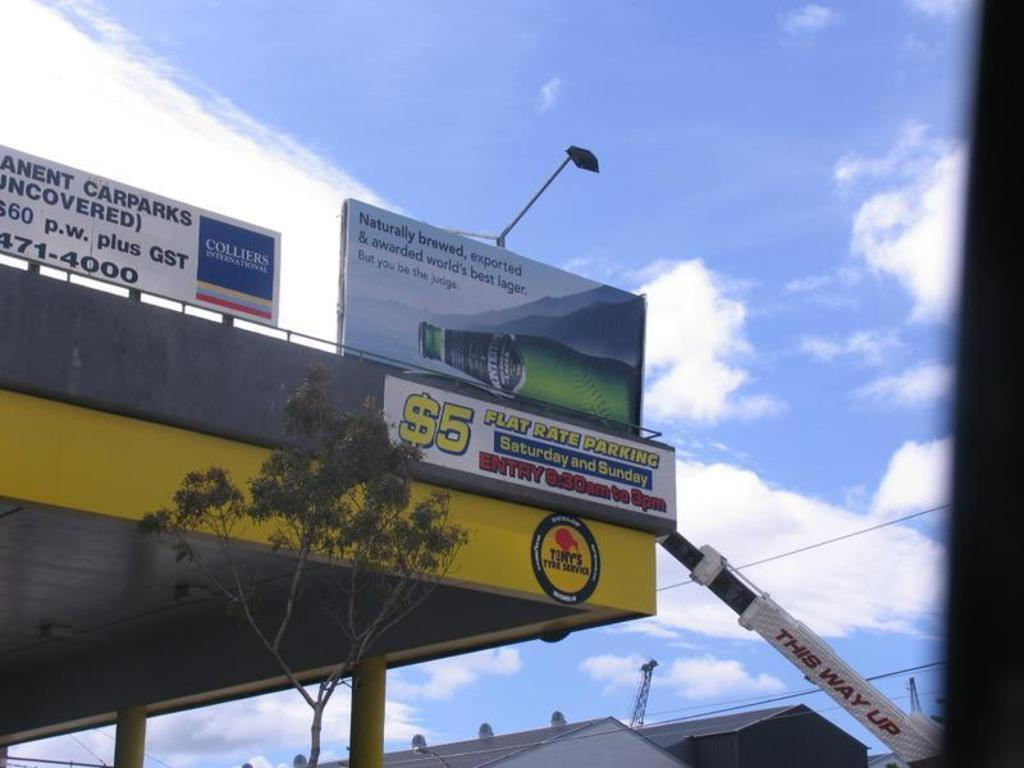<image>
Write a terse but informative summary of the picture. A billboard advertising $5 flat rate parking on the weekend. 